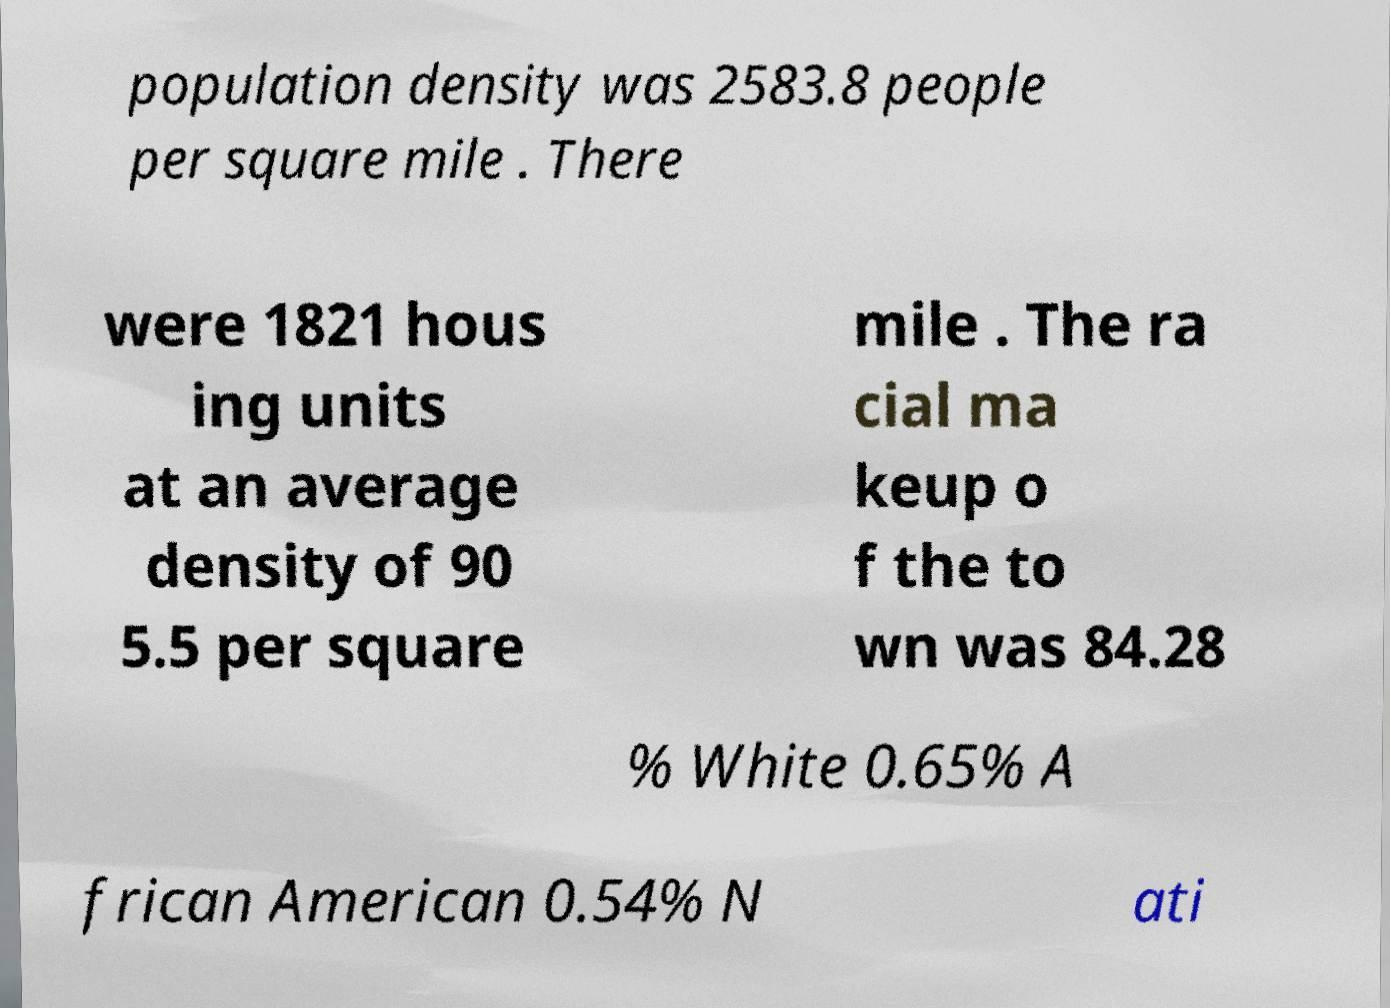What messages or text are displayed in this image? I need them in a readable, typed format. population density was 2583.8 people per square mile . There were 1821 hous ing units at an average density of 90 5.5 per square mile . The ra cial ma keup o f the to wn was 84.28 % White 0.65% A frican American 0.54% N ati 